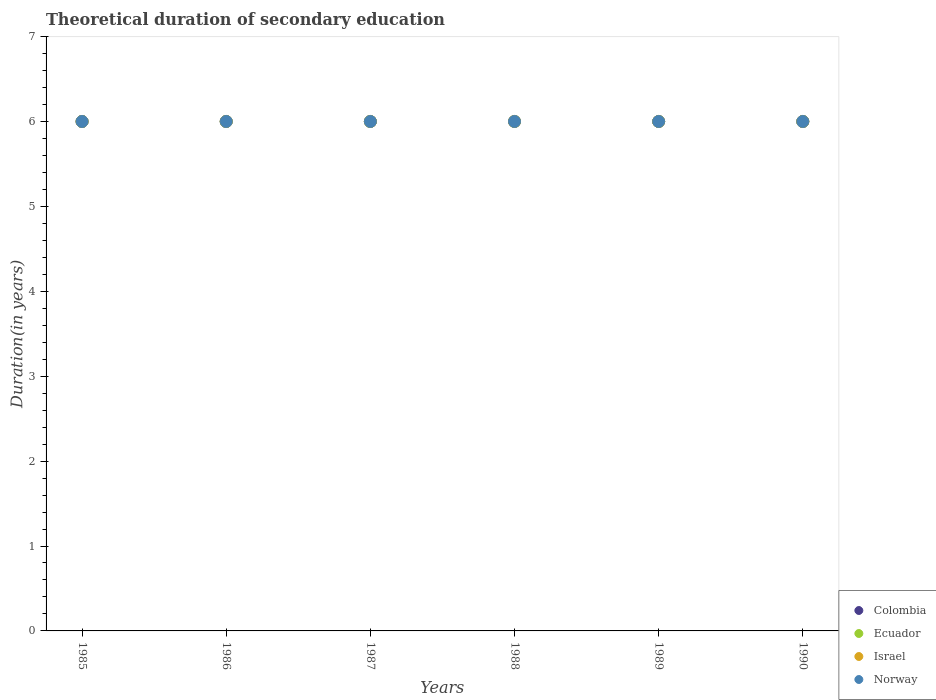How many different coloured dotlines are there?
Provide a short and direct response. 4. What is the total theoretical duration of secondary education in Israel in 1990?
Offer a terse response. 6. In which year was the total theoretical duration of secondary education in Israel minimum?
Your answer should be very brief. 1985. What is the total total theoretical duration of secondary education in Norway in the graph?
Your response must be concise. 36. What is the difference between the total theoretical duration of secondary education in Ecuador in 1986 and the total theoretical duration of secondary education in Norway in 1987?
Your response must be concise. 0. What is the average total theoretical duration of secondary education in Israel per year?
Keep it short and to the point. 6. In the year 1990, what is the difference between the total theoretical duration of secondary education in Israel and total theoretical duration of secondary education in Ecuador?
Ensure brevity in your answer.  0. In how many years, is the total theoretical duration of secondary education in Israel greater than 3 years?
Provide a short and direct response. 6. In how many years, is the total theoretical duration of secondary education in Ecuador greater than the average total theoretical duration of secondary education in Ecuador taken over all years?
Provide a succinct answer. 0. Is it the case that in every year, the sum of the total theoretical duration of secondary education in Israel and total theoretical duration of secondary education in Norway  is greater than the sum of total theoretical duration of secondary education in Colombia and total theoretical duration of secondary education in Ecuador?
Make the answer very short. No. How many dotlines are there?
Your answer should be compact. 4. What is the difference between two consecutive major ticks on the Y-axis?
Your answer should be very brief. 1. Are the values on the major ticks of Y-axis written in scientific E-notation?
Ensure brevity in your answer.  No. Does the graph contain grids?
Ensure brevity in your answer.  No. What is the title of the graph?
Your answer should be very brief. Theoretical duration of secondary education. Does "Brazil" appear as one of the legend labels in the graph?
Keep it short and to the point. No. What is the label or title of the Y-axis?
Provide a succinct answer. Duration(in years). What is the Duration(in years) in Colombia in 1985?
Keep it short and to the point. 6. What is the Duration(in years) in Ecuador in 1985?
Keep it short and to the point. 6. What is the Duration(in years) of Norway in 1985?
Your answer should be compact. 6. What is the Duration(in years) in Colombia in 1987?
Your answer should be compact. 6. What is the Duration(in years) in Ecuador in 1987?
Provide a succinct answer. 6. What is the Duration(in years) in Israel in 1987?
Give a very brief answer. 6. What is the Duration(in years) of Colombia in 1988?
Offer a terse response. 6. What is the Duration(in years) of Norway in 1989?
Your answer should be compact. 6. What is the Duration(in years) in Colombia in 1990?
Provide a short and direct response. 6. What is the Duration(in years) in Israel in 1990?
Give a very brief answer. 6. What is the Duration(in years) of Norway in 1990?
Provide a short and direct response. 6. Across all years, what is the maximum Duration(in years) in Norway?
Your response must be concise. 6. Across all years, what is the minimum Duration(in years) in Ecuador?
Your answer should be very brief. 6. Across all years, what is the minimum Duration(in years) in Israel?
Your answer should be very brief. 6. What is the total Duration(in years) of Ecuador in the graph?
Make the answer very short. 36. What is the total Duration(in years) in Norway in the graph?
Your answer should be compact. 36. What is the difference between the Duration(in years) of Ecuador in 1985 and that in 1986?
Provide a succinct answer. 0. What is the difference between the Duration(in years) of Israel in 1985 and that in 1986?
Offer a very short reply. 0. What is the difference between the Duration(in years) of Norway in 1985 and that in 1986?
Ensure brevity in your answer.  0. What is the difference between the Duration(in years) of Israel in 1985 and that in 1988?
Provide a succinct answer. 0. What is the difference between the Duration(in years) in Norway in 1985 and that in 1988?
Your answer should be very brief. 0. What is the difference between the Duration(in years) of Colombia in 1985 and that in 1989?
Your answer should be very brief. 0. What is the difference between the Duration(in years) in Ecuador in 1985 and that in 1989?
Give a very brief answer. 0. What is the difference between the Duration(in years) of Israel in 1985 and that in 1990?
Your answer should be compact. 0. What is the difference between the Duration(in years) of Israel in 1986 and that in 1987?
Keep it short and to the point. 0. What is the difference between the Duration(in years) in Norway in 1986 and that in 1987?
Ensure brevity in your answer.  0. What is the difference between the Duration(in years) in Ecuador in 1986 and that in 1988?
Your response must be concise. 0. What is the difference between the Duration(in years) of Israel in 1986 and that in 1988?
Ensure brevity in your answer.  0. What is the difference between the Duration(in years) in Norway in 1986 and that in 1988?
Offer a terse response. 0. What is the difference between the Duration(in years) in Colombia in 1986 and that in 1989?
Make the answer very short. 0. What is the difference between the Duration(in years) in Ecuador in 1986 and that in 1989?
Your response must be concise. 0. What is the difference between the Duration(in years) in Norway in 1986 and that in 1989?
Give a very brief answer. 0. What is the difference between the Duration(in years) in Colombia in 1986 and that in 1990?
Your response must be concise. 0. What is the difference between the Duration(in years) in Israel in 1986 and that in 1990?
Your answer should be very brief. 0. What is the difference between the Duration(in years) in Ecuador in 1987 and that in 1988?
Your answer should be very brief. 0. What is the difference between the Duration(in years) of Israel in 1987 and that in 1988?
Offer a terse response. 0. What is the difference between the Duration(in years) of Norway in 1987 and that in 1988?
Provide a succinct answer. 0. What is the difference between the Duration(in years) of Colombia in 1987 and that in 1989?
Your response must be concise. 0. What is the difference between the Duration(in years) of Colombia in 1987 and that in 1990?
Your answer should be very brief. 0. What is the difference between the Duration(in years) in Ecuador in 1987 and that in 1990?
Your answer should be very brief. 0. What is the difference between the Duration(in years) in Colombia in 1988 and that in 1990?
Your answer should be very brief. 0. What is the difference between the Duration(in years) in Ecuador in 1988 and that in 1990?
Your answer should be very brief. 0. What is the difference between the Duration(in years) in Israel in 1988 and that in 1990?
Provide a succinct answer. 0. What is the difference between the Duration(in years) in Norway in 1988 and that in 1990?
Provide a short and direct response. 0. What is the difference between the Duration(in years) of Ecuador in 1989 and that in 1990?
Your answer should be compact. 0. What is the difference between the Duration(in years) of Israel in 1989 and that in 1990?
Make the answer very short. 0. What is the difference between the Duration(in years) of Norway in 1989 and that in 1990?
Provide a short and direct response. 0. What is the difference between the Duration(in years) of Colombia in 1985 and the Duration(in years) of Ecuador in 1986?
Give a very brief answer. 0. What is the difference between the Duration(in years) in Colombia in 1985 and the Duration(in years) in Israel in 1986?
Ensure brevity in your answer.  0. What is the difference between the Duration(in years) of Colombia in 1985 and the Duration(in years) of Norway in 1986?
Provide a succinct answer. 0. What is the difference between the Duration(in years) in Israel in 1985 and the Duration(in years) in Norway in 1986?
Keep it short and to the point. 0. What is the difference between the Duration(in years) of Colombia in 1985 and the Duration(in years) of Ecuador in 1987?
Your answer should be very brief. 0. What is the difference between the Duration(in years) in Colombia in 1985 and the Duration(in years) in Israel in 1987?
Ensure brevity in your answer.  0. What is the difference between the Duration(in years) of Israel in 1985 and the Duration(in years) of Norway in 1987?
Offer a terse response. 0. What is the difference between the Duration(in years) of Colombia in 1985 and the Duration(in years) of Norway in 1988?
Offer a very short reply. 0. What is the difference between the Duration(in years) of Ecuador in 1985 and the Duration(in years) of Israel in 1988?
Your answer should be compact. 0. What is the difference between the Duration(in years) in Ecuador in 1985 and the Duration(in years) in Norway in 1988?
Provide a short and direct response. 0. What is the difference between the Duration(in years) in Israel in 1985 and the Duration(in years) in Norway in 1988?
Keep it short and to the point. 0. What is the difference between the Duration(in years) in Ecuador in 1985 and the Duration(in years) in Norway in 1989?
Keep it short and to the point. 0. What is the difference between the Duration(in years) of Israel in 1985 and the Duration(in years) of Norway in 1989?
Give a very brief answer. 0. What is the difference between the Duration(in years) in Colombia in 1985 and the Duration(in years) in Ecuador in 1990?
Make the answer very short. 0. What is the difference between the Duration(in years) of Colombia in 1985 and the Duration(in years) of Israel in 1990?
Offer a terse response. 0. What is the difference between the Duration(in years) of Colombia in 1985 and the Duration(in years) of Norway in 1990?
Keep it short and to the point. 0. What is the difference between the Duration(in years) of Ecuador in 1985 and the Duration(in years) of Israel in 1990?
Your answer should be very brief. 0. What is the difference between the Duration(in years) in Ecuador in 1985 and the Duration(in years) in Norway in 1990?
Offer a very short reply. 0. What is the difference between the Duration(in years) in Israel in 1985 and the Duration(in years) in Norway in 1990?
Ensure brevity in your answer.  0. What is the difference between the Duration(in years) in Israel in 1986 and the Duration(in years) in Norway in 1987?
Offer a terse response. 0. What is the difference between the Duration(in years) of Colombia in 1986 and the Duration(in years) of Israel in 1988?
Offer a very short reply. 0. What is the difference between the Duration(in years) in Colombia in 1986 and the Duration(in years) in Norway in 1988?
Make the answer very short. 0. What is the difference between the Duration(in years) in Colombia in 1986 and the Duration(in years) in Ecuador in 1989?
Ensure brevity in your answer.  0. What is the difference between the Duration(in years) of Ecuador in 1986 and the Duration(in years) of Norway in 1990?
Ensure brevity in your answer.  0. What is the difference between the Duration(in years) of Colombia in 1987 and the Duration(in years) of Ecuador in 1988?
Your answer should be very brief. 0. What is the difference between the Duration(in years) of Colombia in 1987 and the Duration(in years) of Israel in 1988?
Offer a very short reply. 0. What is the difference between the Duration(in years) in Ecuador in 1987 and the Duration(in years) in Israel in 1988?
Offer a terse response. 0. What is the difference between the Duration(in years) of Ecuador in 1987 and the Duration(in years) of Norway in 1988?
Make the answer very short. 0. What is the difference between the Duration(in years) of Israel in 1987 and the Duration(in years) of Norway in 1988?
Offer a very short reply. 0. What is the difference between the Duration(in years) of Colombia in 1987 and the Duration(in years) of Ecuador in 1989?
Offer a terse response. 0. What is the difference between the Duration(in years) in Ecuador in 1987 and the Duration(in years) in Israel in 1989?
Keep it short and to the point. 0. What is the difference between the Duration(in years) of Israel in 1987 and the Duration(in years) of Norway in 1989?
Ensure brevity in your answer.  0. What is the difference between the Duration(in years) of Colombia in 1987 and the Duration(in years) of Israel in 1990?
Your answer should be very brief. 0. What is the difference between the Duration(in years) in Colombia in 1987 and the Duration(in years) in Norway in 1990?
Ensure brevity in your answer.  0. What is the difference between the Duration(in years) in Ecuador in 1987 and the Duration(in years) in Israel in 1990?
Keep it short and to the point. 0. What is the difference between the Duration(in years) in Israel in 1987 and the Duration(in years) in Norway in 1990?
Your answer should be compact. 0. What is the difference between the Duration(in years) of Ecuador in 1988 and the Duration(in years) of Norway in 1989?
Your answer should be very brief. 0. What is the difference between the Duration(in years) in Colombia in 1988 and the Duration(in years) in Norway in 1990?
Your response must be concise. 0. What is the difference between the Duration(in years) of Ecuador in 1988 and the Duration(in years) of Norway in 1990?
Your answer should be compact. 0. What is the difference between the Duration(in years) of Colombia in 1989 and the Duration(in years) of Israel in 1990?
Keep it short and to the point. 0. What is the difference between the Duration(in years) of Colombia in 1989 and the Duration(in years) of Norway in 1990?
Keep it short and to the point. 0. What is the average Duration(in years) in Ecuador per year?
Provide a succinct answer. 6. What is the average Duration(in years) in Israel per year?
Give a very brief answer. 6. In the year 1985, what is the difference between the Duration(in years) of Colombia and Duration(in years) of Israel?
Give a very brief answer. 0. In the year 1985, what is the difference between the Duration(in years) in Ecuador and Duration(in years) in Israel?
Keep it short and to the point. 0. In the year 1986, what is the difference between the Duration(in years) of Colombia and Duration(in years) of Ecuador?
Give a very brief answer. 0. In the year 1986, what is the difference between the Duration(in years) in Colombia and Duration(in years) in Israel?
Offer a terse response. 0. In the year 1986, what is the difference between the Duration(in years) of Israel and Duration(in years) of Norway?
Make the answer very short. 0. In the year 1987, what is the difference between the Duration(in years) of Colombia and Duration(in years) of Ecuador?
Your answer should be compact. 0. In the year 1987, what is the difference between the Duration(in years) of Colombia and Duration(in years) of Israel?
Your answer should be very brief. 0. In the year 1987, what is the difference between the Duration(in years) in Colombia and Duration(in years) in Norway?
Your answer should be compact. 0. In the year 1987, what is the difference between the Duration(in years) in Ecuador and Duration(in years) in Israel?
Your answer should be compact. 0. In the year 1988, what is the difference between the Duration(in years) in Colombia and Duration(in years) in Israel?
Keep it short and to the point. 0. In the year 1988, what is the difference between the Duration(in years) of Colombia and Duration(in years) of Norway?
Provide a short and direct response. 0. In the year 1988, what is the difference between the Duration(in years) in Ecuador and Duration(in years) in Israel?
Keep it short and to the point. 0. In the year 1989, what is the difference between the Duration(in years) in Colombia and Duration(in years) in Ecuador?
Keep it short and to the point. 0. In the year 1989, what is the difference between the Duration(in years) of Colombia and Duration(in years) of Israel?
Give a very brief answer. 0. In the year 1989, what is the difference between the Duration(in years) in Israel and Duration(in years) in Norway?
Make the answer very short. 0. In the year 1990, what is the difference between the Duration(in years) of Colombia and Duration(in years) of Ecuador?
Your answer should be very brief. 0. In the year 1990, what is the difference between the Duration(in years) in Colombia and Duration(in years) in Israel?
Make the answer very short. 0. In the year 1990, what is the difference between the Duration(in years) in Colombia and Duration(in years) in Norway?
Ensure brevity in your answer.  0. What is the ratio of the Duration(in years) of Colombia in 1985 to that in 1986?
Keep it short and to the point. 1. What is the ratio of the Duration(in years) of Norway in 1985 to that in 1986?
Provide a short and direct response. 1. What is the ratio of the Duration(in years) in Colombia in 1985 to that in 1987?
Give a very brief answer. 1. What is the ratio of the Duration(in years) of Israel in 1985 to that in 1987?
Ensure brevity in your answer.  1. What is the ratio of the Duration(in years) in Colombia in 1985 to that in 1988?
Provide a succinct answer. 1. What is the ratio of the Duration(in years) in Ecuador in 1985 to that in 1988?
Offer a terse response. 1. What is the ratio of the Duration(in years) of Israel in 1985 to that in 1988?
Make the answer very short. 1. What is the ratio of the Duration(in years) of Ecuador in 1985 to that in 1989?
Your answer should be compact. 1. What is the ratio of the Duration(in years) in Israel in 1985 to that in 1989?
Give a very brief answer. 1. What is the ratio of the Duration(in years) of Norway in 1985 to that in 1989?
Ensure brevity in your answer.  1. What is the ratio of the Duration(in years) in Colombia in 1985 to that in 1990?
Your answer should be compact. 1. What is the ratio of the Duration(in years) of Ecuador in 1985 to that in 1990?
Keep it short and to the point. 1. What is the ratio of the Duration(in years) in Israel in 1985 to that in 1990?
Offer a terse response. 1. What is the ratio of the Duration(in years) of Norway in 1985 to that in 1990?
Make the answer very short. 1. What is the ratio of the Duration(in years) of Ecuador in 1986 to that in 1987?
Your answer should be very brief. 1. What is the ratio of the Duration(in years) in Norway in 1986 to that in 1987?
Your answer should be compact. 1. What is the ratio of the Duration(in years) in Colombia in 1986 to that in 1989?
Make the answer very short. 1. What is the ratio of the Duration(in years) of Israel in 1986 to that in 1989?
Give a very brief answer. 1. What is the ratio of the Duration(in years) of Colombia in 1986 to that in 1990?
Make the answer very short. 1. What is the ratio of the Duration(in years) in Ecuador in 1986 to that in 1990?
Your answer should be very brief. 1. What is the ratio of the Duration(in years) in Israel in 1986 to that in 1990?
Give a very brief answer. 1. What is the ratio of the Duration(in years) in Ecuador in 1987 to that in 1988?
Offer a terse response. 1. What is the ratio of the Duration(in years) in Israel in 1987 to that in 1988?
Your response must be concise. 1. What is the ratio of the Duration(in years) of Norway in 1987 to that in 1988?
Ensure brevity in your answer.  1. What is the ratio of the Duration(in years) in Colombia in 1987 to that in 1989?
Make the answer very short. 1. What is the ratio of the Duration(in years) of Israel in 1987 to that in 1989?
Provide a succinct answer. 1. What is the ratio of the Duration(in years) in Ecuador in 1987 to that in 1990?
Offer a terse response. 1. What is the ratio of the Duration(in years) in Norway in 1987 to that in 1990?
Ensure brevity in your answer.  1. What is the ratio of the Duration(in years) in Ecuador in 1988 to that in 1989?
Keep it short and to the point. 1. What is the ratio of the Duration(in years) of Israel in 1988 to that in 1989?
Give a very brief answer. 1. What is the ratio of the Duration(in years) of Norway in 1988 to that in 1989?
Offer a very short reply. 1. What is the ratio of the Duration(in years) of Norway in 1988 to that in 1990?
Your answer should be very brief. 1. What is the ratio of the Duration(in years) in Colombia in 1989 to that in 1990?
Give a very brief answer. 1. What is the ratio of the Duration(in years) in Israel in 1989 to that in 1990?
Keep it short and to the point. 1. What is the difference between the highest and the second highest Duration(in years) in Colombia?
Your answer should be compact. 0. What is the difference between the highest and the second highest Duration(in years) of Ecuador?
Your answer should be very brief. 0. What is the difference between the highest and the second highest Duration(in years) of Israel?
Offer a terse response. 0. What is the difference between the highest and the lowest Duration(in years) of Norway?
Provide a short and direct response. 0. 